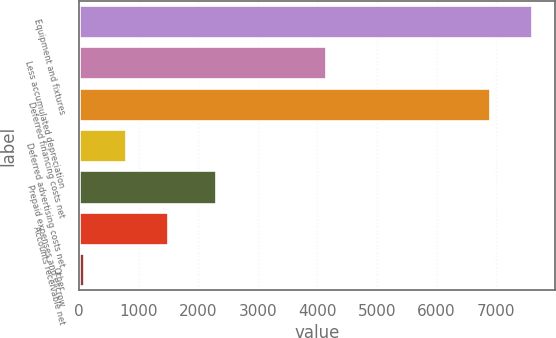Convert chart. <chart><loc_0><loc_0><loc_500><loc_500><bar_chart><fcel>Equipment and fixtures<fcel>Less accumulated depreciation<fcel>Deferred financing costs net<fcel>Deferred advertising costs net<fcel>Prepaid expenses and escrow<fcel>Accounts receivable net<fcel>Other<nl><fcel>7602.8<fcel>4136<fcel>6899<fcel>780.8<fcel>2305<fcel>1484.6<fcel>77<nl></chart> 